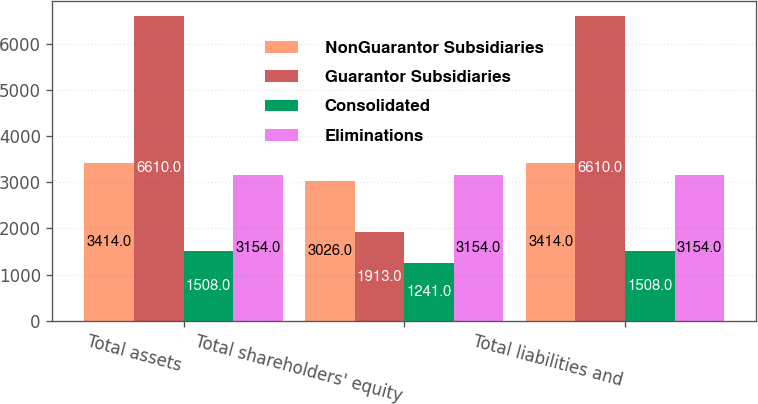Convert chart to OTSL. <chart><loc_0><loc_0><loc_500><loc_500><stacked_bar_chart><ecel><fcel>Total assets<fcel>Total shareholders' equity<fcel>Total liabilities and<nl><fcel>NonGuarantor Subsidiaries<fcel>3414<fcel>3026<fcel>3414<nl><fcel>Guarantor Subsidiaries<fcel>6610<fcel>1913<fcel>6610<nl><fcel>Consolidated<fcel>1508<fcel>1241<fcel>1508<nl><fcel>Eliminations<fcel>3154<fcel>3154<fcel>3154<nl></chart> 